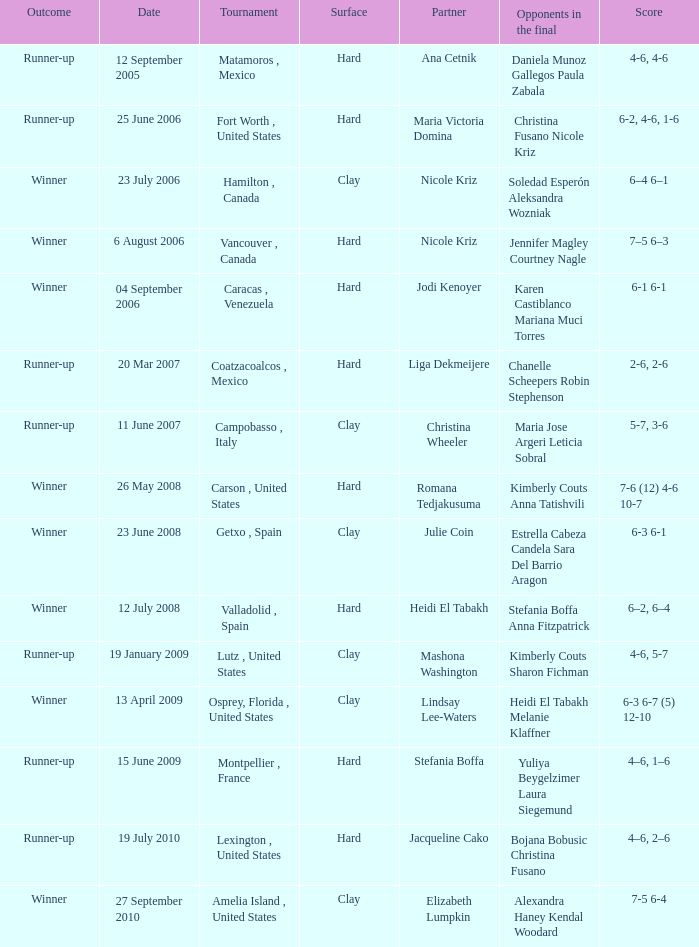When did the match occur where tweedie-yates had jodi kenoyer as their partner? 04 September 2006. 